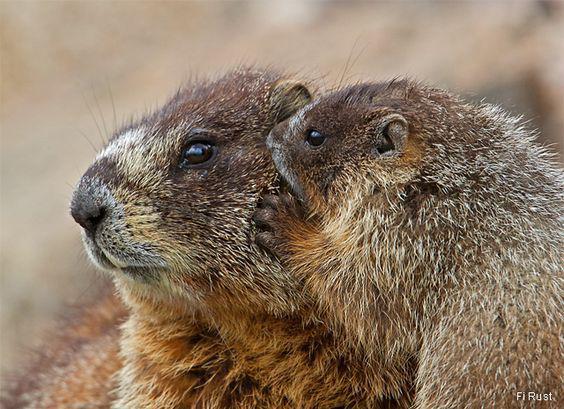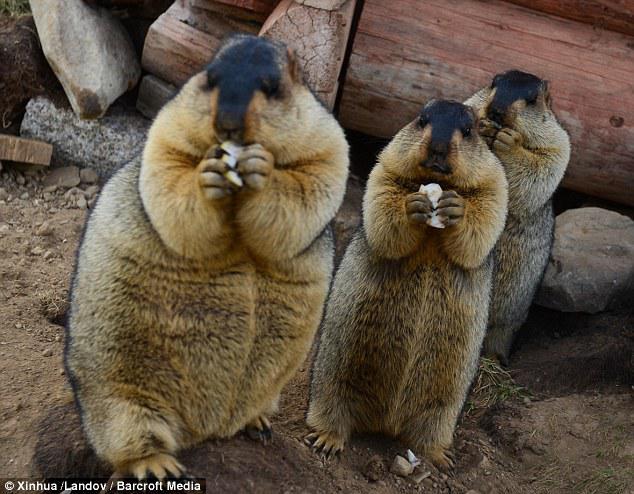The first image is the image on the left, the second image is the image on the right. Examine the images to the left and right. Is the description "there are no less then 3 animals in the right pic" accurate? Answer yes or no. Yes. 